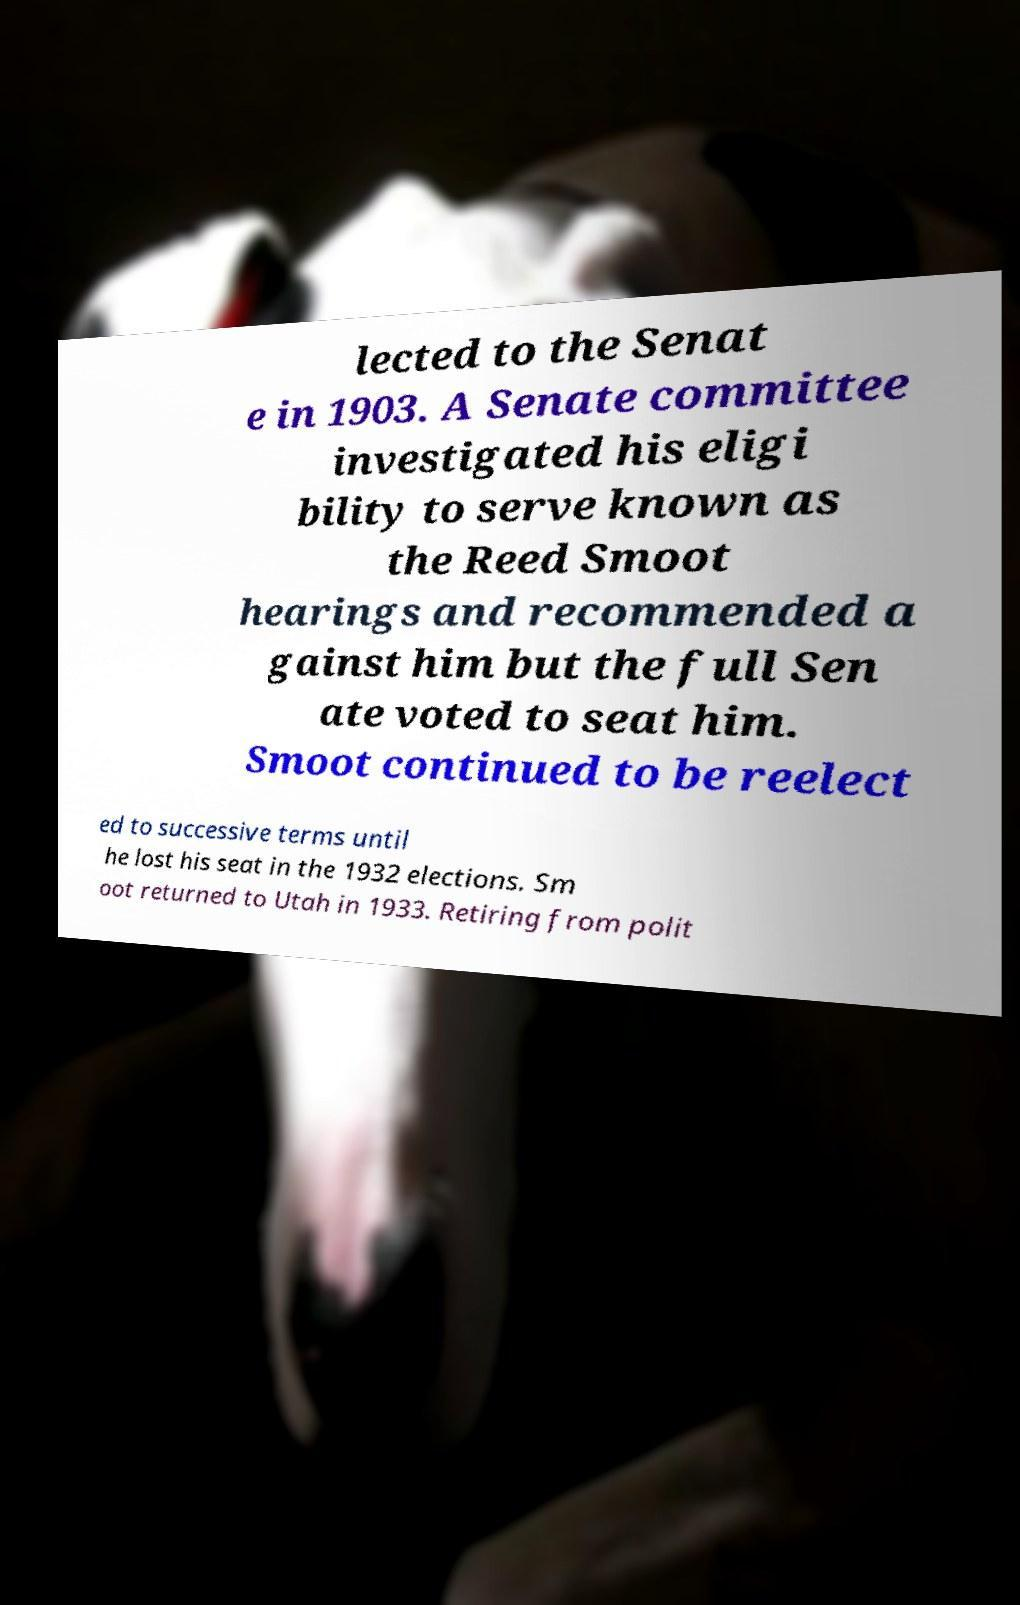Can you accurately transcribe the text from the provided image for me? lected to the Senat e in 1903. A Senate committee investigated his eligi bility to serve known as the Reed Smoot hearings and recommended a gainst him but the full Sen ate voted to seat him. Smoot continued to be reelect ed to successive terms until he lost his seat in the 1932 elections. Sm oot returned to Utah in 1933. Retiring from polit 